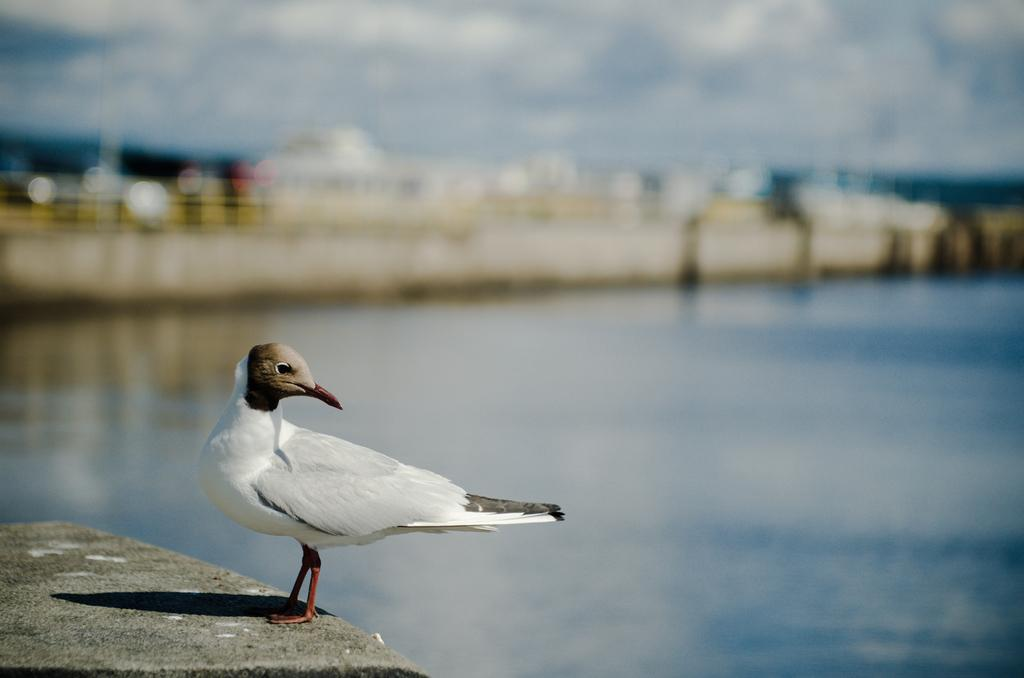What is the main characteristic of the background in the image? The background portion of the picture is blurred. What natural element can be seen in the image? There is water visible in the image. Where is the bird located in the image? The bird is on a concrete surface in the image. What topic is being discussed by the bird in the image? There is no indication in the image that the bird is discussing any topic. 